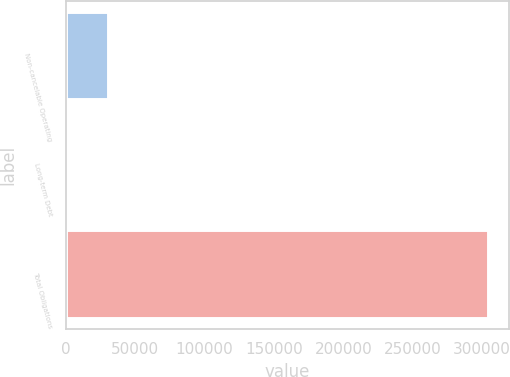Convert chart to OTSL. <chart><loc_0><loc_0><loc_500><loc_500><bar_chart><fcel>Non-cancelable Operating<fcel>Long-term Debt<fcel>Total Obligations<nl><fcel>30530.8<fcel>142<fcel>304030<nl></chart> 